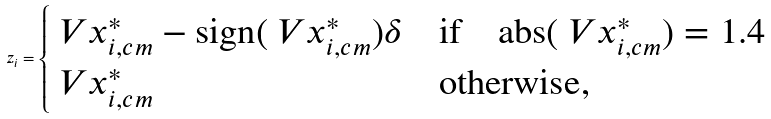<formula> <loc_0><loc_0><loc_500><loc_500>z _ { i } = \begin{cases} \ V { x } _ { i , c m } ^ { * } - \text {sign} ( \ V { x } _ { i , c m } ^ { * } ) \delta & \text {if} \quad \text {abs} ( \ V { x } _ { i , c m } ^ { * } ) = 1 . 4 \\ \ V { x } _ { i , c m } ^ { * } & \text {otherwise} , \end{cases}</formula> 